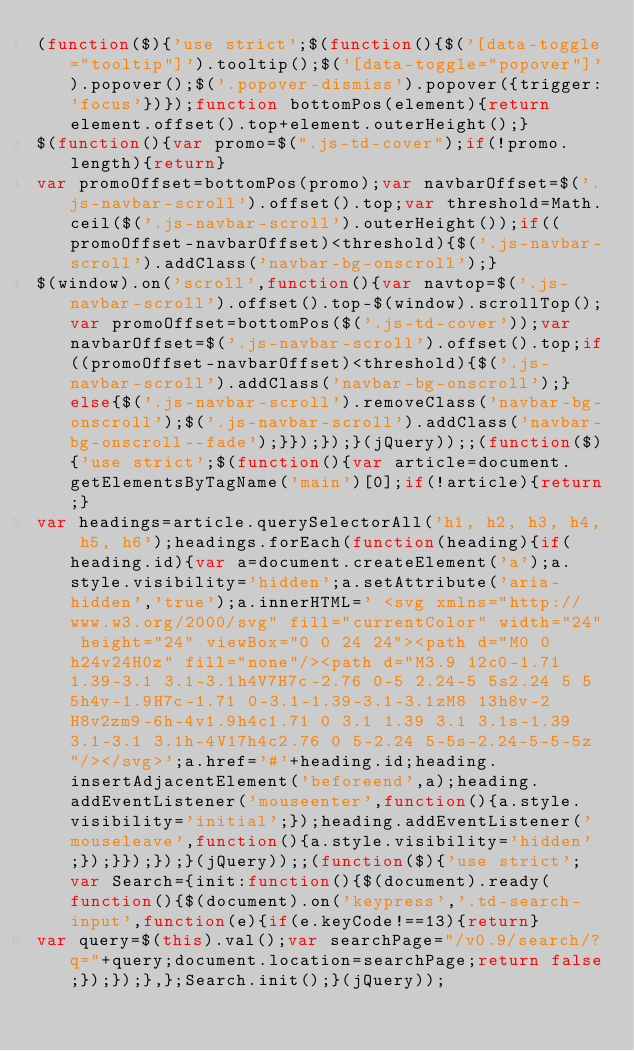<code> <loc_0><loc_0><loc_500><loc_500><_JavaScript_>(function($){'use strict';$(function(){$('[data-toggle="tooltip"]').tooltip();$('[data-toggle="popover"]').popover();$('.popover-dismiss').popover({trigger:'focus'})});function bottomPos(element){return element.offset().top+element.outerHeight();}
$(function(){var promo=$(".js-td-cover");if(!promo.length){return}
var promoOffset=bottomPos(promo);var navbarOffset=$('.js-navbar-scroll').offset().top;var threshold=Math.ceil($('.js-navbar-scroll').outerHeight());if((promoOffset-navbarOffset)<threshold){$('.js-navbar-scroll').addClass('navbar-bg-onscroll');}
$(window).on('scroll',function(){var navtop=$('.js-navbar-scroll').offset().top-$(window).scrollTop();var promoOffset=bottomPos($('.js-td-cover'));var navbarOffset=$('.js-navbar-scroll').offset().top;if((promoOffset-navbarOffset)<threshold){$('.js-navbar-scroll').addClass('navbar-bg-onscroll');}else{$('.js-navbar-scroll').removeClass('navbar-bg-onscroll');$('.js-navbar-scroll').addClass('navbar-bg-onscroll--fade');}});});}(jQuery));;(function($){'use strict';$(function(){var article=document.getElementsByTagName('main')[0];if(!article){return;}
var headings=article.querySelectorAll('h1, h2, h3, h4, h5, h6');headings.forEach(function(heading){if(heading.id){var a=document.createElement('a');a.style.visibility='hidden';a.setAttribute('aria-hidden','true');a.innerHTML=' <svg xmlns="http://www.w3.org/2000/svg" fill="currentColor" width="24" height="24" viewBox="0 0 24 24"><path d="M0 0h24v24H0z" fill="none"/><path d="M3.9 12c0-1.71 1.39-3.1 3.1-3.1h4V7H7c-2.76 0-5 2.24-5 5s2.24 5 5 5h4v-1.9H7c-1.71 0-3.1-1.39-3.1-3.1zM8 13h8v-2H8v2zm9-6h-4v1.9h4c1.71 0 3.1 1.39 3.1 3.1s-1.39 3.1-3.1 3.1h-4V17h4c2.76 0 5-2.24 5-5s-2.24-5-5-5z"/></svg>';a.href='#'+heading.id;heading.insertAdjacentElement('beforeend',a);heading.addEventListener('mouseenter',function(){a.style.visibility='initial';});heading.addEventListener('mouseleave',function(){a.style.visibility='hidden';});}});});}(jQuery));;(function($){'use strict';var Search={init:function(){$(document).ready(function(){$(document).on('keypress','.td-search-input',function(e){if(e.keyCode!==13){return}
var query=$(this).val();var searchPage="/v0.9/search/?q="+query;document.location=searchPage;return false;});});},};Search.init();}(jQuery));</code> 